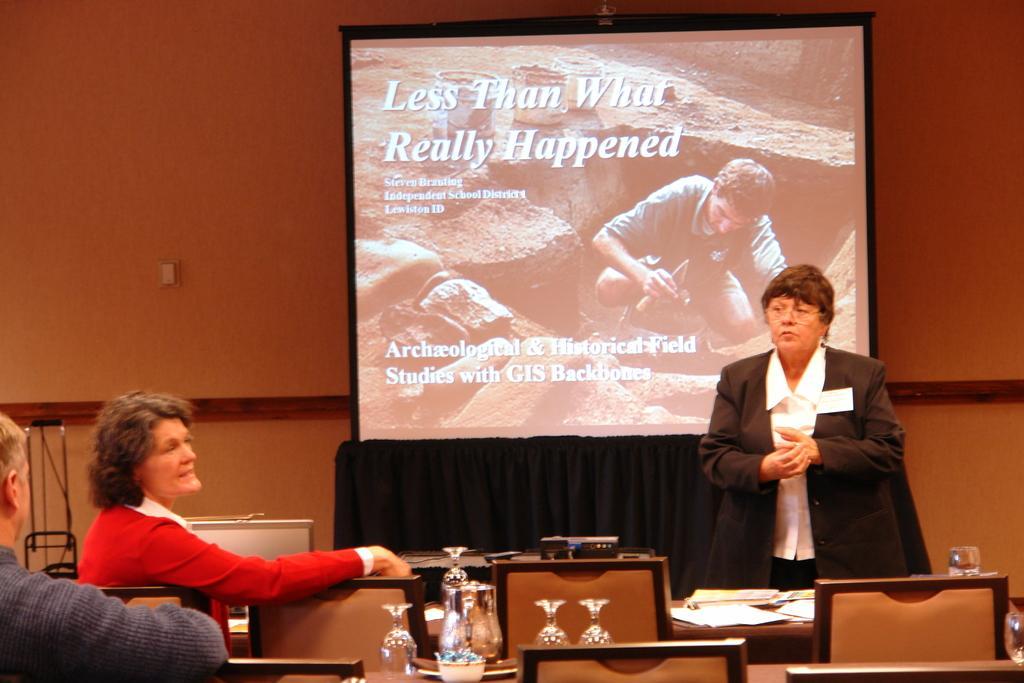Please provide a concise description of this image. In this picture we can see two woman and one men where two are sitting on chair and one is standing and looking at them and in front of them we can see glasses, bowl, papers on table and in background we can see screen, wall. 